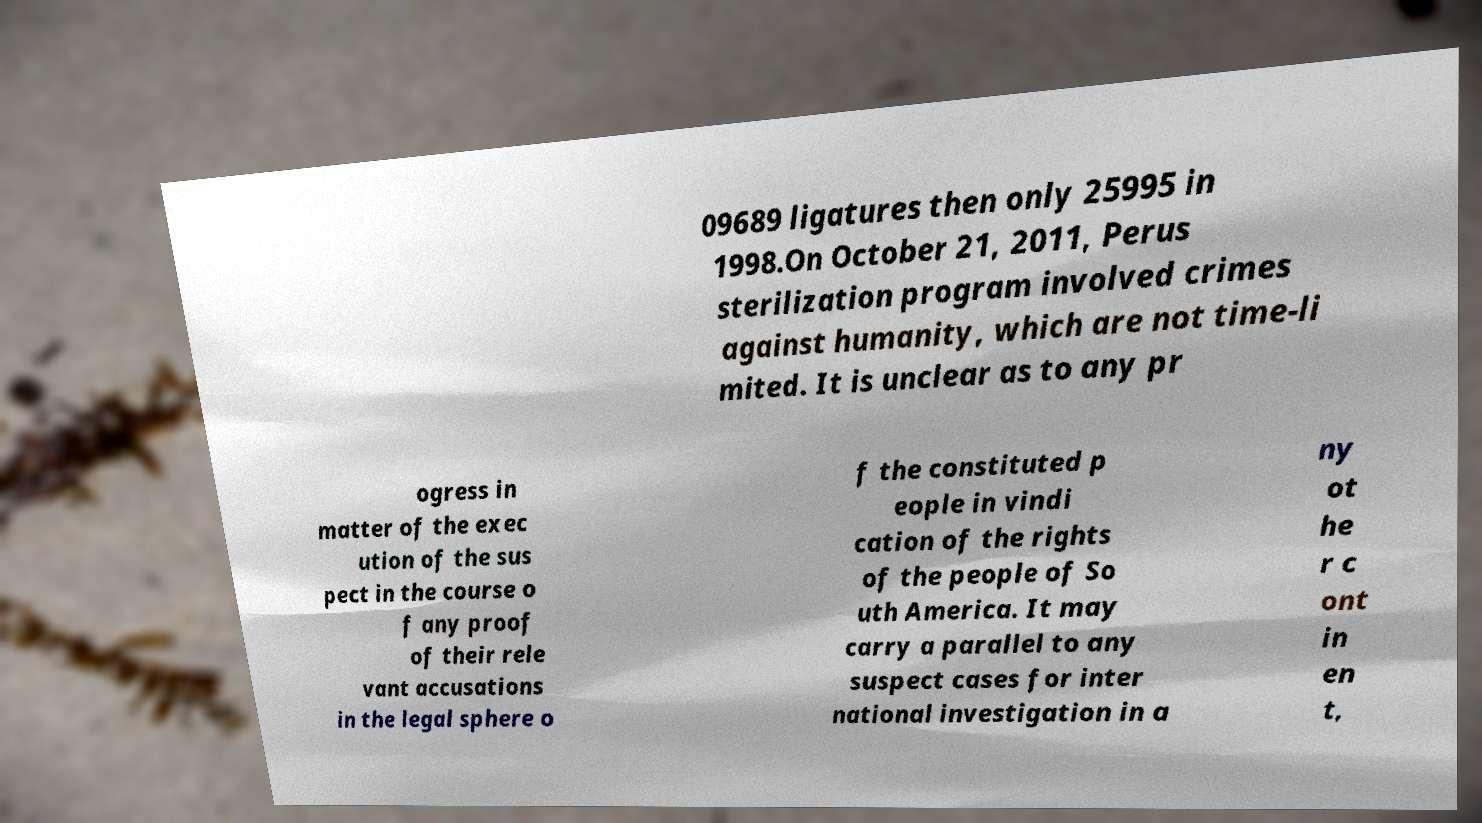Could you extract and type out the text from this image? 09689 ligatures then only 25995 in 1998.On October 21, 2011, Perus sterilization program involved crimes against humanity, which are not time-li mited. It is unclear as to any pr ogress in matter of the exec ution of the sus pect in the course o f any proof of their rele vant accusations in the legal sphere o f the constituted p eople in vindi cation of the rights of the people of So uth America. It may carry a parallel to any suspect cases for inter national investigation in a ny ot he r c ont in en t, 